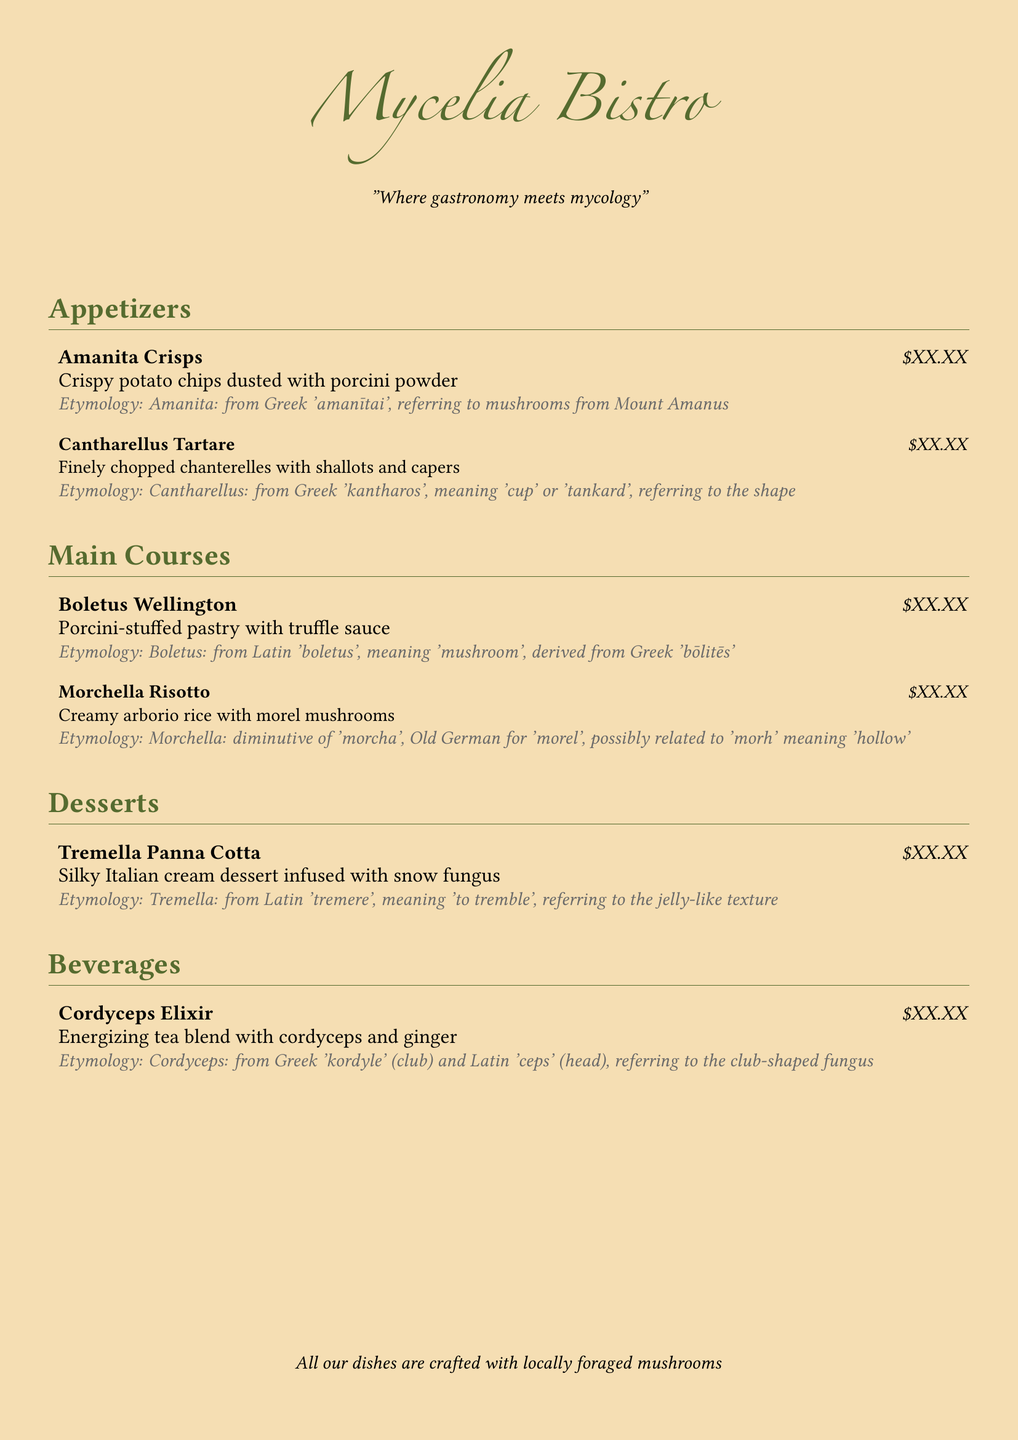What is the name of the bistro? The bistro's name is prominently displayed at the top of the menu.
Answer: Mycelia Bistro What is the price of Morchella Risotto? Each dish has a price indicated after the dish name, but the price is consistently represented as \$XX.XX.
Answer: \$XX.XX What type of dessert features Tremella? The menu describes a specific dessert that includes Tremella, referring to its function in the dish.
Answer: Panna Cotta What kind of mushrooms are used in the appetizers? The appetizer menu highlights specific types of mushrooms associated with each dish.
Answer: Porcini and Chanterelles What is the etymological origin of 'Amanita'? The etymology is provided for each dish and is referenced in a specific section of the appetizers.
Answer: From Greek 'amanītai' Which main course is described as stuffed with truffle sauce? The main course provides details on the filling and flavor profile of the dish.
Answer: Boletus Wellington What beverage is featured with cordyceps? A specific beverage relates to cordyceps and is found under the beverage section.
Answer: Elixir How is the Tremella dessert described in texture? The description of the dessert includes a specific characteristic tied to the term 'Tremella.'
Answer: Jelly-like What theme does the restaurant's tagline imply? The tagline expresses a fusion concept important to the bistro's identity.
Answer: Gastronomy meets mycology 